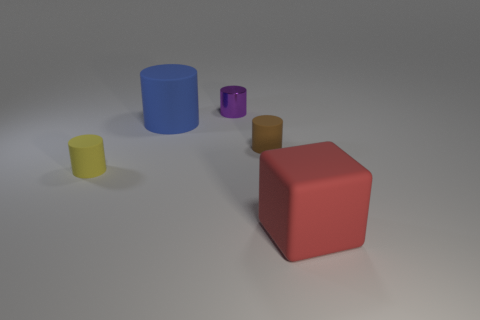What color is the rubber cylinder that is both on the left side of the metal thing and in front of the large rubber cylinder?
Give a very brief answer. Yellow. There is a red thing; are there any small yellow objects behind it?
Make the answer very short. Yes. What number of matte objects are in front of the large object that is behind the large cube?
Ensure brevity in your answer.  3. What is the size of the yellow cylinder that is the same material as the large red cube?
Your response must be concise. Small. What is the size of the purple object?
Provide a succinct answer. Small. Is the tiny brown cylinder made of the same material as the yellow object?
Keep it short and to the point. Yes. How many cylinders are yellow rubber objects or blue things?
Offer a very short reply. 2. There is a rubber cylinder to the left of the large object that is behind the red cube; what color is it?
Provide a short and direct response. Yellow. What number of blue matte things are left of the rubber cylinder left of the big thing that is on the left side of the metallic cylinder?
Offer a terse response. 0. Is the shape of the large rubber object that is behind the large red cube the same as the matte thing on the left side of the large matte cylinder?
Make the answer very short. Yes. 